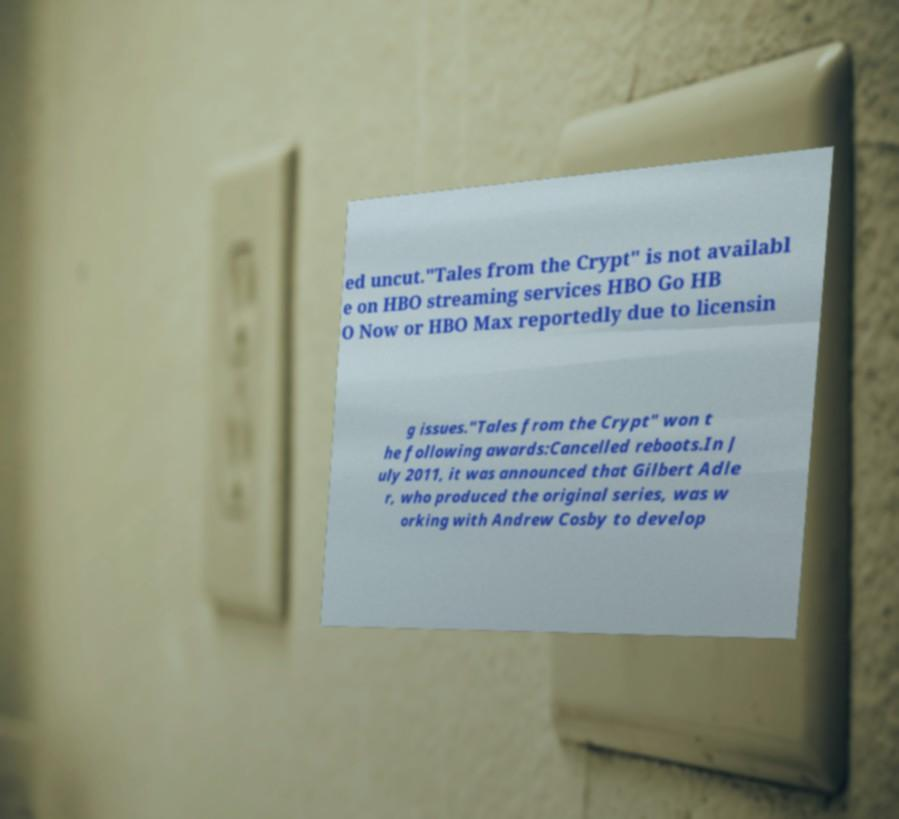Can you read and provide the text displayed in the image?This photo seems to have some interesting text. Can you extract and type it out for me? ed uncut."Tales from the Crypt" is not availabl e on HBO streaming services HBO Go HB O Now or HBO Max reportedly due to licensin g issues."Tales from the Crypt" won t he following awards:Cancelled reboots.In J uly 2011, it was announced that Gilbert Adle r, who produced the original series, was w orking with Andrew Cosby to develop 